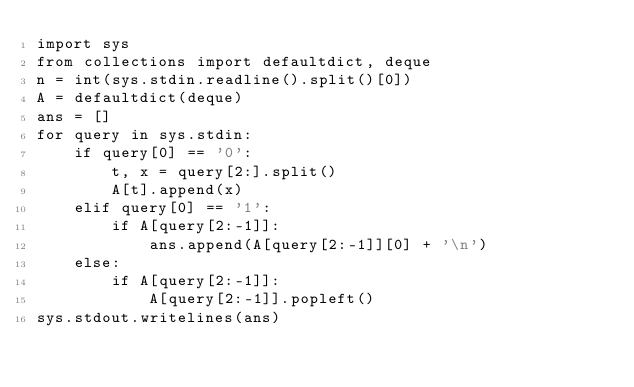<code> <loc_0><loc_0><loc_500><loc_500><_Python_>import sys
from collections import defaultdict, deque
n = int(sys.stdin.readline().split()[0])
A = defaultdict(deque)
ans = []
for query in sys.stdin:
    if query[0] == '0':
        t, x = query[2:].split()
        A[t].append(x)
    elif query[0] == '1':
        if A[query[2:-1]]:
            ans.append(A[query[2:-1]][0] + '\n')
    else:
        if A[query[2:-1]]:
            A[query[2:-1]].popleft()
sys.stdout.writelines(ans)

</code> 